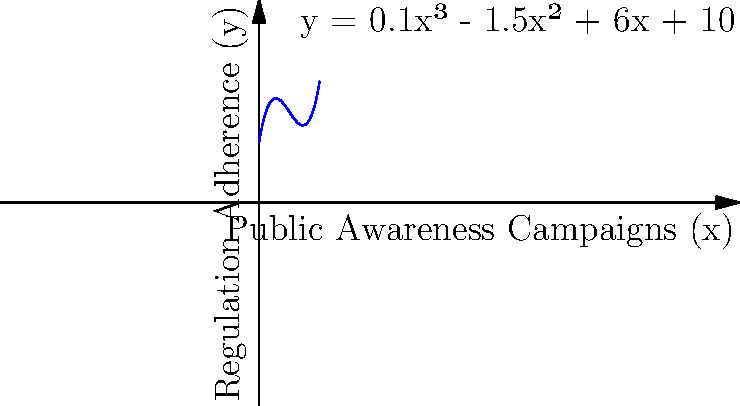The graph represents the relationship between public awareness campaigns (x) and regulation adherence (y) using the polynomial function $y = 0.1x^3 - 1.5x^2 + 6x + 10$. At which point does the effectiveness of awareness campaigns start to diminish, as indicated by a decreasing rate of improvement in regulation adherence? To find the point where the effectiveness of awareness campaigns starts to diminish, we need to:

1. Find the derivative of the function: 
   $\frac{dy}{dx} = 0.3x^2 - 3x + 6$

2. Find the second derivative:
   $\frac{d^2y}{dx^2} = 0.6x - 3$

3. Set the second derivative to zero to find the inflection point:
   $0.6x - 3 = 0$
   $0.6x = 3$
   $x = 5$

4. Verify that this is a point where the curve changes from concave up to concave down:
   For $x < 5$, $\frac{d^2y}{dx^2} < 0$ (concave down)
   For $x > 5$, $\frac{d^2y}{dx^2} > 0$ (concave up)

5. Calculate the y-value at $x = 5$:
   $y = 0.1(5^3) - 1.5(5^2) + 6(5) + 10 = 35$

Therefore, the point $(5, 35)$ is where the effectiveness of awareness campaigns starts to diminish, as indicated by a decreasing rate of improvement in regulation adherence.
Answer: (5, 35) 